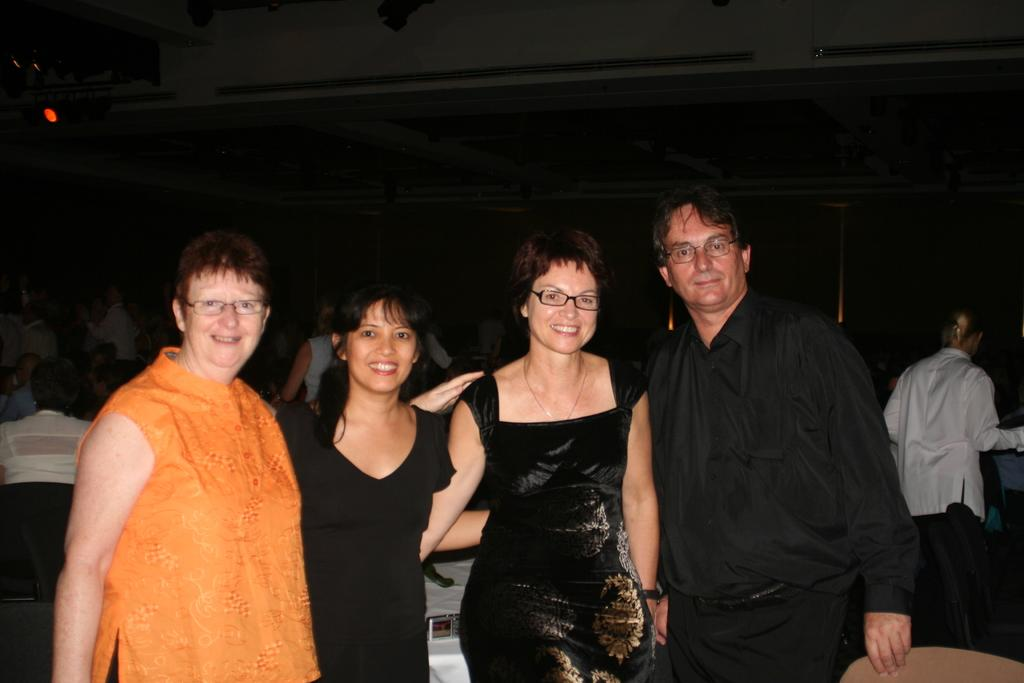How many people are standing together in the image? There are four people standing together in the image. What is the facial expression of the people in the image? The four people are smiling. What can be observed in the background of the image? There are other busy people visible in the background of the image. What type of leaf is being used as a prop in the image? There is no leaf present in the image; it features four people standing together and smiling. 